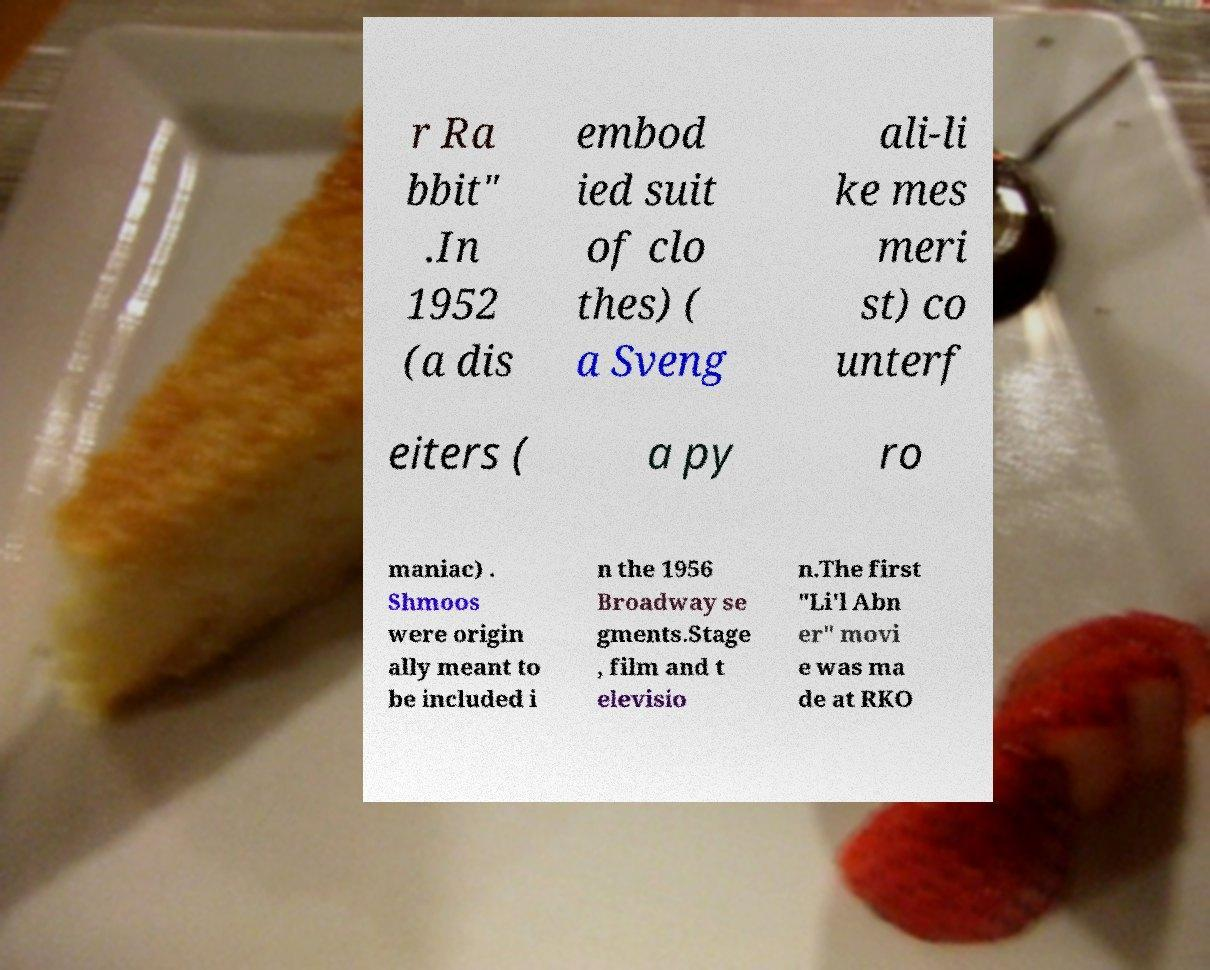Could you extract and type out the text from this image? r Ra bbit" .In 1952 (a dis embod ied suit of clo thes) ( a Sveng ali-li ke mes meri st) co unterf eiters ( a py ro maniac) . Shmoos were origin ally meant to be included i n the 1956 Broadway se gments.Stage , film and t elevisio n.The first "Li'l Abn er" movi e was ma de at RKO 